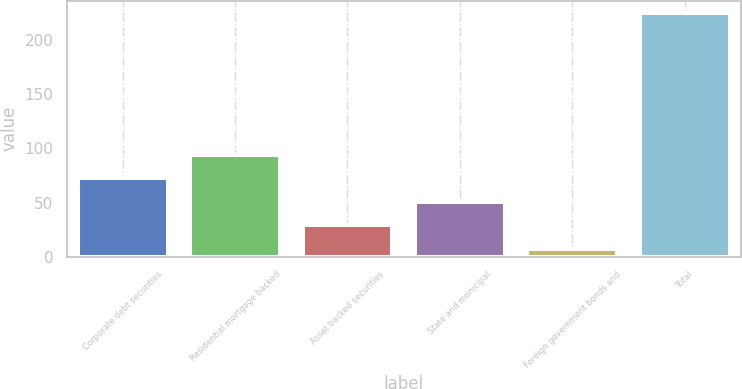Convert chart. <chart><loc_0><loc_0><loc_500><loc_500><bar_chart><fcel>Corporate debt securities<fcel>Residential mortgage backed<fcel>Asset backed securities<fcel>State and municipal<fcel>Foreign government bonds and<fcel>Total<nl><fcel>72.4<fcel>94.2<fcel>28.8<fcel>50.6<fcel>7<fcel>225<nl></chart> 